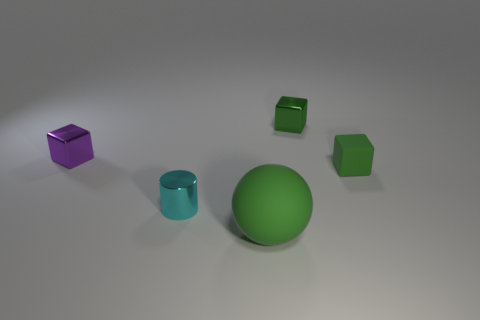Add 2 small cyan shiny objects. How many objects exist? 7 Subtract all cubes. How many objects are left? 2 Subtract all tiny yellow cylinders. Subtract all tiny shiny cubes. How many objects are left? 3 Add 2 small things. How many small things are left? 6 Add 1 large green spheres. How many large green spheres exist? 2 Subtract 0 cyan cubes. How many objects are left? 5 